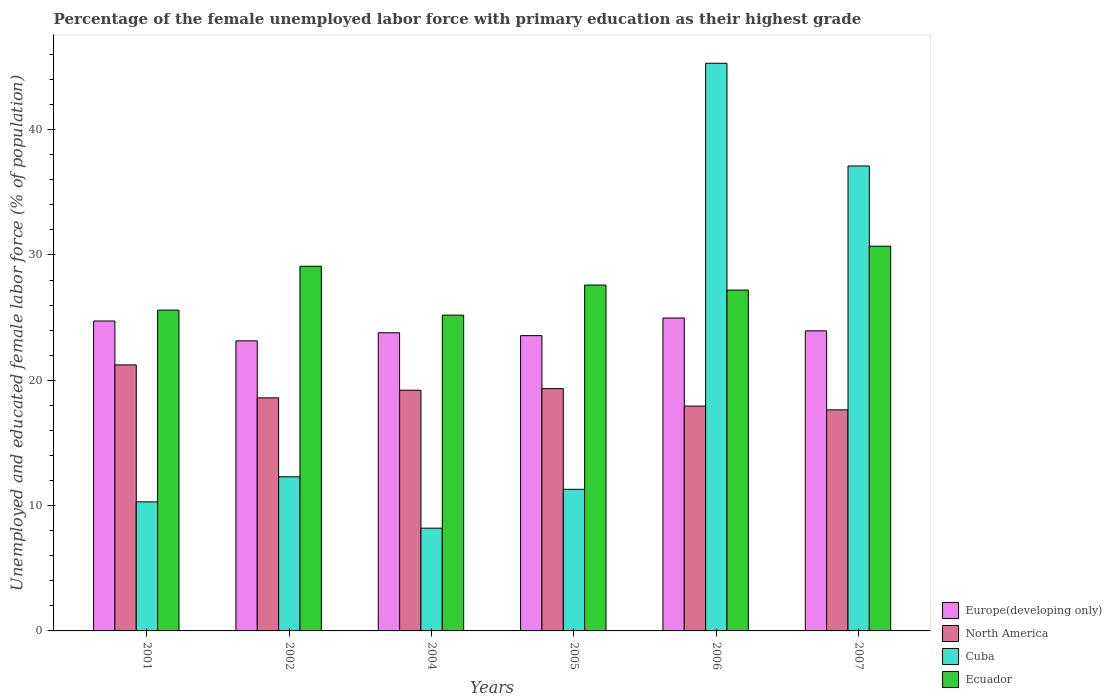How many different coloured bars are there?
Give a very brief answer. 4. How many groups of bars are there?
Give a very brief answer. 6. Are the number of bars per tick equal to the number of legend labels?
Offer a terse response. Yes. Are the number of bars on each tick of the X-axis equal?
Make the answer very short. Yes. How many bars are there on the 1st tick from the right?
Give a very brief answer. 4. What is the label of the 1st group of bars from the left?
Give a very brief answer. 2001. In how many cases, is the number of bars for a given year not equal to the number of legend labels?
Give a very brief answer. 0. What is the percentage of the unemployed female labor force with primary education in North America in 2001?
Give a very brief answer. 21.23. Across all years, what is the maximum percentage of the unemployed female labor force with primary education in Cuba?
Your response must be concise. 45.3. Across all years, what is the minimum percentage of the unemployed female labor force with primary education in Europe(developing only)?
Make the answer very short. 23.15. In which year was the percentage of the unemployed female labor force with primary education in Ecuador maximum?
Give a very brief answer. 2007. What is the total percentage of the unemployed female labor force with primary education in Cuba in the graph?
Offer a very short reply. 124.5. What is the difference between the percentage of the unemployed female labor force with primary education in Cuba in 2002 and that in 2007?
Make the answer very short. -24.8. What is the difference between the percentage of the unemployed female labor force with primary education in Ecuador in 2005 and the percentage of the unemployed female labor force with primary education in North America in 2004?
Provide a short and direct response. 8.39. What is the average percentage of the unemployed female labor force with primary education in Cuba per year?
Give a very brief answer. 20.75. In the year 2002, what is the difference between the percentage of the unemployed female labor force with primary education in Ecuador and percentage of the unemployed female labor force with primary education in Cuba?
Your answer should be very brief. 16.8. In how many years, is the percentage of the unemployed female labor force with primary education in Ecuador greater than 26 %?
Ensure brevity in your answer.  4. What is the ratio of the percentage of the unemployed female labor force with primary education in Ecuador in 2005 to that in 2006?
Keep it short and to the point. 1.01. Is the percentage of the unemployed female labor force with primary education in Cuba in 2002 less than that in 2004?
Provide a short and direct response. No. What is the difference between the highest and the second highest percentage of the unemployed female labor force with primary education in Ecuador?
Keep it short and to the point. 1.6. What is the difference between the highest and the lowest percentage of the unemployed female labor force with primary education in Cuba?
Your response must be concise. 37.1. In how many years, is the percentage of the unemployed female labor force with primary education in North America greater than the average percentage of the unemployed female labor force with primary education in North America taken over all years?
Make the answer very short. 3. Is the sum of the percentage of the unemployed female labor force with primary education in North America in 2002 and 2005 greater than the maximum percentage of the unemployed female labor force with primary education in Europe(developing only) across all years?
Offer a terse response. Yes. Is it the case that in every year, the sum of the percentage of the unemployed female labor force with primary education in Cuba and percentage of the unemployed female labor force with primary education in Ecuador is greater than the sum of percentage of the unemployed female labor force with primary education in North America and percentage of the unemployed female labor force with primary education in Europe(developing only)?
Provide a short and direct response. No. What does the 1st bar from the left in 2006 represents?
Give a very brief answer. Europe(developing only). What does the 4th bar from the right in 2006 represents?
Your answer should be very brief. Europe(developing only). Is it the case that in every year, the sum of the percentage of the unemployed female labor force with primary education in Europe(developing only) and percentage of the unemployed female labor force with primary education in North America is greater than the percentage of the unemployed female labor force with primary education in Ecuador?
Give a very brief answer. Yes. Are all the bars in the graph horizontal?
Your answer should be compact. No. How many years are there in the graph?
Ensure brevity in your answer.  6. Does the graph contain any zero values?
Give a very brief answer. No. Does the graph contain grids?
Give a very brief answer. No. How are the legend labels stacked?
Offer a terse response. Vertical. What is the title of the graph?
Your answer should be very brief. Percentage of the female unemployed labor force with primary education as their highest grade. What is the label or title of the X-axis?
Offer a terse response. Years. What is the label or title of the Y-axis?
Your response must be concise. Unemployed and educated female labor force (% of population). What is the Unemployed and educated female labor force (% of population) of Europe(developing only) in 2001?
Offer a terse response. 24.73. What is the Unemployed and educated female labor force (% of population) of North America in 2001?
Make the answer very short. 21.23. What is the Unemployed and educated female labor force (% of population) in Cuba in 2001?
Ensure brevity in your answer.  10.3. What is the Unemployed and educated female labor force (% of population) in Ecuador in 2001?
Make the answer very short. 25.6. What is the Unemployed and educated female labor force (% of population) of Europe(developing only) in 2002?
Ensure brevity in your answer.  23.15. What is the Unemployed and educated female labor force (% of population) of North America in 2002?
Offer a very short reply. 18.6. What is the Unemployed and educated female labor force (% of population) of Cuba in 2002?
Make the answer very short. 12.3. What is the Unemployed and educated female labor force (% of population) of Ecuador in 2002?
Make the answer very short. 29.1. What is the Unemployed and educated female labor force (% of population) of Europe(developing only) in 2004?
Ensure brevity in your answer.  23.79. What is the Unemployed and educated female labor force (% of population) in North America in 2004?
Provide a succinct answer. 19.21. What is the Unemployed and educated female labor force (% of population) of Cuba in 2004?
Offer a very short reply. 8.2. What is the Unemployed and educated female labor force (% of population) of Ecuador in 2004?
Provide a succinct answer. 25.2. What is the Unemployed and educated female labor force (% of population) of Europe(developing only) in 2005?
Make the answer very short. 23.57. What is the Unemployed and educated female labor force (% of population) of North America in 2005?
Provide a succinct answer. 19.33. What is the Unemployed and educated female labor force (% of population) in Cuba in 2005?
Your answer should be very brief. 11.3. What is the Unemployed and educated female labor force (% of population) of Ecuador in 2005?
Offer a terse response. 27.6. What is the Unemployed and educated female labor force (% of population) of Europe(developing only) in 2006?
Keep it short and to the point. 24.97. What is the Unemployed and educated female labor force (% of population) of North America in 2006?
Ensure brevity in your answer.  17.94. What is the Unemployed and educated female labor force (% of population) of Cuba in 2006?
Ensure brevity in your answer.  45.3. What is the Unemployed and educated female labor force (% of population) of Ecuador in 2006?
Your answer should be very brief. 27.2. What is the Unemployed and educated female labor force (% of population) of Europe(developing only) in 2007?
Provide a short and direct response. 23.95. What is the Unemployed and educated female labor force (% of population) of North America in 2007?
Keep it short and to the point. 17.64. What is the Unemployed and educated female labor force (% of population) of Cuba in 2007?
Make the answer very short. 37.1. What is the Unemployed and educated female labor force (% of population) in Ecuador in 2007?
Offer a very short reply. 30.7. Across all years, what is the maximum Unemployed and educated female labor force (% of population) in Europe(developing only)?
Your answer should be very brief. 24.97. Across all years, what is the maximum Unemployed and educated female labor force (% of population) of North America?
Your answer should be very brief. 21.23. Across all years, what is the maximum Unemployed and educated female labor force (% of population) of Cuba?
Offer a terse response. 45.3. Across all years, what is the maximum Unemployed and educated female labor force (% of population) in Ecuador?
Your response must be concise. 30.7. Across all years, what is the minimum Unemployed and educated female labor force (% of population) in Europe(developing only)?
Keep it short and to the point. 23.15. Across all years, what is the minimum Unemployed and educated female labor force (% of population) in North America?
Your answer should be very brief. 17.64. Across all years, what is the minimum Unemployed and educated female labor force (% of population) in Cuba?
Ensure brevity in your answer.  8.2. Across all years, what is the minimum Unemployed and educated female labor force (% of population) in Ecuador?
Offer a terse response. 25.2. What is the total Unemployed and educated female labor force (% of population) of Europe(developing only) in the graph?
Keep it short and to the point. 144.15. What is the total Unemployed and educated female labor force (% of population) of North America in the graph?
Offer a very short reply. 113.96. What is the total Unemployed and educated female labor force (% of population) of Cuba in the graph?
Provide a short and direct response. 124.5. What is the total Unemployed and educated female labor force (% of population) of Ecuador in the graph?
Your answer should be compact. 165.4. What is the difference between the Unemployed and educated female labor force (% of population) of Europe(developing only) in 2001 and that in 2002?
Your response must be concise. 1.59. What is the difference between the Unemployed and educated female labor force (% of population) of North America in 2001 and that in 2002?
Your answer should be compact. 2.63. What is the difference between the Unemployed and educated female labor force (% of population) in Cuba in 2001 and that in 2002?
Your answer should be compact. -2. What is the difference between the Unemployed and educated female labor force (% of population) of Europe(developing only) in 2001 and that in 2004?
Provide a short and direct response. 0.94. What is the difference between the Unemployed and educated female labor force (% of population) in North America in 2001 and that in 2004?
Offer a very short reply. 2.02. What is the difference between the Unemployed and educated female labor force (% of population) of Cuba in 2001 and that in 2004?
Offer a very short reply. 2.1. What is the difference between the Unemployed and educated female labor force (% of population) of Europe(developing only) in 2001 and that in 2005?
Offer a terse response. 1.17. What is the difference between the Unemployed and educated female labor force (% of population) in North America in 2001 and that in 2005?
Provide a short and direct response. 1.89. What is the difference between the Unemployed and educated female labor force (% of population) of Cuba in 2001 and that in 2005?
Provide a short and direct response. -1. What is the difference between the Unemployed and educated female labor force (% of population) in Ecuador in 2001 and that in 2005?
Ensure brevity in your answer.  -2. What is the difference between the Unemployed and educated female labor force (% of population) in Europe(developing only) in 2001 and that in 2006?
Ensure brevity in your answer.  -0.24. What is the difference between the Unemployed and educated female labor force (% of population) of North America in 2001 and that in 2006?
Offer a terse response. 3.29. What is the difference between the Unemployed and educated female labor force (% of population) in Cuba in 2001 and that in 2006?
Provide a succinct answer. -35. What is the difference between the Unemployed and educated female labor force (% of population) in Europe(developing only) in 2001 and that in 2007?
Offer a terse response. 0.79. What is the difference between the Unemployed and educated female labor force (% of population) of North America in 2001 and that in 2007?
Your answer should be compact. 3.59. What is the difference between the Unemployed and educated female labor force (% of population) in Cuba in 2001 and that in 2007?
Make the answer very short. -26.8. What is the difference between the Unemployed and educated female labor force (% of population) in Ecuador in 2001 and that in 2007?
Your response must be concise. -5.1. What is the difference between the Unemployed and educated female labor force (% of population) of Europe(developing only) in 2002 and that in 2004?
Your answer should be very brief. -0.65. What is the difference between the Unemployed and educated female labor force (% of population) of North America in 2002 and that in 2004?
Provide a short and direct response. -0.61. What is the difference between the Unemployed and educated female labor force (% of population) in Cuba in 2002 and that in 2004?
Provide a short and direct response. 4.1. What is the difference between the Unemployed and educated female labor force (% of population) of Ecuador in 2002 and that in 2004?
Ensure brevity in your answer.  3.9. What is the difference between the Unemployed and educated female labor force (% of population) of Europe(developing only) in 2002 and that in 2005?
Provide a succinct answer. -0.42. What is the difference between the Unemployed and educated female labor force (% of population) of North America in 2002 and that in 2005?
Ensure brevity in your answer.  -0.74. What is the difference between the Unemployed and educated female labor force (% of population) of Cuba in 2002 and that in 2005?
Make the answer very short. 1. What is the difference between the Unemployed and educated female labor force (% of population) of Europe(developing only) in 2002 and that in 2006?
Your answer should be compact. -1.82. What is the difference between the Unemployed and educated female labor force (% of population) of North America in 2002 and that in 2006?
Your response must be concise. 0.66. What is the difference between the Unemployed and educated female labor force (% of population) of Cuba in 2002 and that in 2006?
Offer a terse response. -33. What is the difference between the Unemployed and educated female labor force (% of population) of Ecuador in 2002 and that in 2006?
Keep it short and to the point. 1.9. What is the difference between the Unemployed and educated female labor force (% of population) in Europe(developing only) in 2002 and that in 2007?
Give a very brief answer. -0.8. What is the difference between the Unemployed and educated female labor force (% of population) of North America in 2002 and that in 2007?
Make the answer very short. 0.96. What is the difference between the Unemployed and educated female labor force (% of population) of Cuba in 2002 and that in 2007?
Ensure brevity in your answer.  -24.8. What is the difference between the Unemployed and educated female labor force (% of population) of Ecuador in 2002 and that in 2007?
Your answer should be very brief. -1.6. What is the difference between the Unemployed and educated female labor force (% of population) in Europe(developing only) in 2004 and that in 2005?
Your answer should be very brief. 0.23. What is the difference between the Unemployed and educated female labor force (% of population) of North America in 2004 and that in 2005?
Offer a terse response. -0.13. What is the difference between the Unemployed and educated female labor force (% of population) in Europe(developing only) in 2004 and that in 2006?
Your response must be concise. -1.18. What is the difference between the Unemployed and educated female labor force (% of population) in North America in 2004 and that in 2006?
Provide a succinct answer. 1.26. What is the difference between the Unemployed and educated female labor force (% of population) in Cuba in 2004 and that in 2006?
Offer a very short reply. -37.1. What is the difference between the Unemployed and educated female labor force (% of population) in Europe(developing only) in 2004 and that in 2007?
Provide a short and direct response. -0.15. What is the difference between the Unemployed and educated female labor force (% of population) in North America in 2004 and that in 2007?
Keep it short and to the point. 1.56. What is the difference between the Unemployed and educated female labor force (% of population) of Cuba in 2004 and that in 2007?
Your response must be concise. -28.9. What is the difference between the Unemployed and educated female labor force (% of population) of Ecuador in 2004 and that in 2007?
Your response must be concise. -5.5. What is the difference between the Unemployed and educated female labor force (% of population) of Europe(developing only) in 2005 and that in 2006?
Offer a very short reply. -1.4. What is the difference between the Unemployed and educated female labor force (% of population) of North America in 2005 and that in 2006?
Your answer should be compact. 1.39. What is the difference between the Unemployed and educated female labor force (% of population) of Cuba in 2005 and that in 2006?
Your response must be concise. -34. What is the difference between the Unemployed and educated female labor force (% of population) of Europe(developing only) in 2005 and that in 2007?
Keep it short and to the point. -0.38. What is the difference between the Unemployed and educated female labor force (% of population) of North America in 2005 and that in 2007?
Ensure brevity in your answer.  1.69. What is the difference between the Unemployed and educated female labor force (% of population) of Cuba in 2005 and that in 2007?
Your response must be concise. -25.8. What is the difference between the Unemployed and educated female labor force (% of population) of Europe(developing only) in 2006 and that in 2007?
Ensure brevity in your answer.  1.02. What is the difference between the Unemployed and educated female labor force (% of population) of North America in 2006 and that in 2007?
Provide a succinct answer. 0.3. What is the difference between the Unemployed and educated female labor force (% of population) in Cuba in 2006 and that in 2007?
Make the answer very short. 8.2. What is the difference between the Unemployed and educated female labor force (% of population) in Ecuador in 2006 and that in 2007?
Offer a very short reply. -3.5. What is the difference between the Unemployed and educated female labor force (% of population) in Europe(developing only) in 2001 and the Unemployed and educated female labor force (% of population) in North America in 2002?
Your answer should be compact. 6.13. What is the difference between the Unemployed and educated female labor force (% of population) in Europe(developing only) in 2001 and the Unemployed and educated female labor force (% of population) in Cuba in 2002?
Offer a terse response. 12.43. What is the difference between the Unemployed and educated female labor force (% of population) of Europe(developing only) in 2001 and the Unemployed and educated female labor force (% of population) of Ecuador in 2002?
Your answer should be compact. -4.37. What is the difference between the Unemployed and educated female labor force (% of population) of North America in 2001 and the Unemployed and educated female labor force (% of population) of Cuba in 2002?
Your answer should be compact. 8.93. What is the difference between the Unemployed and educated female labor force (% of population) of North America in 2001 and the Unemployed and educated female labor force (% of population) of Ecuador in 2002?
Offer a terse response. -7.87. What is the difference between the Unemployed and educated female labor force (% of population) of Cuba in 2001 and the Unemployed and educated female labor force (% of population) of Ecuador in 2002?
Provide a short and direct response. -18.8. What is the difference between the Unemployed and educated female labor force (% of population) of Europe(developing only) in 2001 and the Unemployed and educated female labor force (% of population) of North America in 2004?
Your response must be concise. 5.53. What is the difference between the Unemployed and educated female labor force (% of population) of Europe(developing only) in 2001 and the Unemployed and educated female labor force (% of population) of Cuba in 2004?
Make the answer very short. 16.53. What is the difference between the Unemployed and educated female labor force (% of population) in Europe(developing only) in 2001 and the Unemployed and educated female labor force (% of population) in Ecuador in 2004?
Keep it short and to the point. -0.47. What is the difference between the Unemployed and educated female labor force (% of population) of North America in 2001 and the Unemployed and educated female labor force (% of population) of Cuba in 2004?
Offer a very short reply. 13.03. What is the difference between the Unemployed and educated female labor force (% of population) of North America in 2001 and the Unemployed and educated female labor force (% of population) of Ecuador in 2004?
Make the answer very short. -3.97. What is the difference between the Unemployed and educated female labor force (% of population) of Cuba in 2001 and the Unemployed and educated female labor force (% of population) of Ecuador in 2004?
Offer a terse response. -14.9. What is the difference between the Unemployed and educated female labor force (% of population) in Europe(developing only) in 2001 and the Unemployed and educated female labor force (% of population) in North America in 2005?
Your answer should be compact. 5.4. What is the difference between the Unemployed and educated female labor force (% of population) of Europe(developing only) in 2001 and the Unemployed and educated female labor force (% of population) of Cuba in 2005?
Provide a short and direct response. 13.43. What is the difference between the Unemployed and educated female labor force (% of population) in Europe(developing only) in 2001 and the Unemployed and educated female labor force (% of population) in Ecuador in 2005?
Offer a terse response. -2.87. What is the difference between the Unemployed and educated female labor force (% of population) in North America in 2001 and the Unemployed and educated female labor force (% of population) in Cuba in 2005?
Offer a very short reply. 9.93. What is the difference between the Unemployed and educated female labor force (% of population) in North America in 2001 and the Unemployed and educated female labor force (% of population) in Ecuador in 2005?
Make the answer very short. -6.37. What is the difference between the Unemployed and educated female labor force (% of population) of Cuba in 2001 and the Unemployed and educated female labor force (% of population) of Ecuador in 2005?
Offer a very short reply. -17.3. What is the difference between the Unemployed and educated female labor force (% of population) in Europe(developing only) in 2001 and the Unemployed and educated female labor force (% of population) in North America in 2006?
Keep it short and to the point. 6.79. What is the difference between the Unemployed and educated female labor force (% of population) of Europe(developing only) in 2001 and the Unemployed and educated female labor force (% of population) of Cuba in 2006?
Your answer should be very brief. -20.57. What is the difference between the Unemployed and educated female labor force (% of population) of Europe(developing only) in 2001 and the Unemployed and educated female labor force (% of population) of Ecuador in 2006?
Provide a succinct answer. -2.47. What is the difference between the Unemployed and educated female labor force (% of population) of North America in 2001 and the Unemployed and educated female labor force (% of population) of Cuba in 2006?
Offer a terse response. -24.07. What is the difference between the Unemployed and educated female labor force (% of population) in North America in 2001 and the Unemployed and educated female labor force (% of population) in Ecuador in 2006?
Make the answer very short. -5.97. What is the difference between the Unemployed and educated female labor force (% of population) of Cuba in 2001 and the Unemployed and educated female labor force (% of population) of Ecuador in 2006?
Your answer should be compact. -16.9. What is the difference between the Unemployed and educated female labor force (% of population) of Europe(developing only) in 2001 and the Unemployed and educated female labor force (% of population) of North America in 2007?
Provide a short and direct response. 7.09. What is the difference between the Unemployed and educated female labor force (% of population) in Europe(developing only) in 2001 and the Unemployed and educated female labor force (% of population) in Cuba in 2007?
Provide a succinct answer. -12.37. What is the difference between the Unemployed and educated female labor force (% of population) of Europe(developing only) in 2001 and the Unemployed and educated female labor force (% of population) of Ecuador in 2007?
Provide a short and direct response. -5.97. What is the difference between the Unemployed and educated female labor force (% of population) of North America in 2001 and the Unemployed and educated female labor force (% of population) of Cuba in 2007?
Offer a very short reply. -15.87. What is the difference between the Unemployed and educated female labor force (% of population) of North America in 2001 and the Unemployed and educated female labor force (% of population) of Ecuador in 2007?
Your answer should be compact. -9.47. What is the difference between the Unemployed and educated female labor force (% of population) of Cuba in 2001 and the Unemployed and educated female labor force (% of population) of Ecuador in 2007?
Your answer should be compact. -20.4. What is the difference between the Unemployed and educated female labor force (% of population) of Europe(developing only) in 2002 and the Unemployed and educated female labor force (% of population) of North America in 2004?
Ensure brevity in your answer.  3.94. What is the difference between the Unemployed and educated female labor force (% of population) of Europe(developing only) in 2002 and the Unemployed and educated female labor force (% of population) of Cuba in 2004?
Provide a succinct answer. 14.95. What is the difference between the Unemployed and educated female labor force (% of population) of Europe(developing only) in 2002 and the Unemployed and educated female labor force (% of population) of Ecuador in 2004?
Keep it short and to the point. -2.05. What is the difference between the Unemployed and educated female labor force (% of population) of North America in 2002 and the Unemployed and educated female labor force (% of population) of Cuba in 2004?
Your answer should be compact. 10.4. What is the difference between the Unemployed and educated female labor force (% of population) in North America in 2002 and the Unemployed and educated female labor force (% of population) in Ecuador in 2004?
Give a very brief answer. -6.6. What is the difference between the Unemployed and educated female labor force (% of population) in Cuba in 2002 and the Unemployed and educated female labor force (% of population) in Ecuador in 2004?
Give a very brief answer. -12.9. What is the difference between the Unemployed and educated female labor force (% of population) in Europe(developing only) in 2002 and the Unemployed and educated female labor force (% of population) in North America in 2005?
Offer a terse response. 3.81. What is the difference between the Unemployed and educated female labor force (% of population) in Europe(developing only) in 2002 and the Unemployed and educated female labor force (% of population) in Cuba in 2005?
Ensure brevity in your answer.  11.85. What is the difference between the Unemployed and educated female labor force (% of population) of Europe(developing only) in 2002 and the Unemployed and educated female labor force (% of population) of Ecuador in 2005?
Provide a short and direct response. -4.45. What is the difference between the Unemployed and educated female labor force (% of population) of North America in 2002 and the Unemployed and educated female labor force (% of population) of Cuba in 2005?
Your answer should be compact. 7.3. What is the difference between the Unemployed and educated female labor force (% of population) in North America in 2002 and the Unemployed and educated female labor force (% of population) in Ecuador in 2005?
Your response must be concise. -9. What is the difference between the Unemployed and educated female labor force (% of population) of Cuba in 2002 and the Unemployed and educated female labor force (% of population) of Ecuador in 2005?
Keep it short and to the point. -15.3. What is the difference between the Unemployed and educated female labor force (% of population) in Europe(developing only) in 2002 and the Unemployed and educated female labor force (% of population) in North America in 2006?
Provide a succinct answer. 5.2. What is the difference between the Unemployed and educated female labor force (% of population) of Europe(developing only) in 2002 and the Unemployed and educated female labor force (% of population) of Cuba in 2006?
Your answer should be very brief. -22.15. What is the difference between the Unemployed and educated female labor force (% of population) of Europe(developing only) in 2002 and the Unemployed and educated female labor force (% of population) of Ecuador in 2006?
Make the answer very short. -4.05. What is the difference between the Unemployed and educated female labor force (% of population) in North America in 2002 and the Unemployed and educated female labor force (% of population) in Cuba in 2006?
Offer a terse response. -26.7. What is the difference between the Unemployed and educated female labor force (% of population) of North America in 2002 and the Unemployed and educated female labor force (% of population) of Ecuador in 2006?
Ensure brevity in your answer.  -8.6. What is the difference between the Unemployed and educated female labor force (% of population) in Cuba in 2002 and the Unemployed and educated female labor force (% of population) in Ecuador in 2006?
Your response must be concise. -14.9. What is the difference between the Unemployed and educated female labor force (% of population) of Europe(developing only) in 2002 and the Unemployed and educated female labor force (% of population) of North America in 2007?
Provide a succinct answer. 5.5. What is the difference between the Unemployed and educated female labor force (% of population) in Europe(developing only) in 2002 and the Unemployed and educated female labor force (% of population) in Cuba in 2007?
Your answer should be very brief. -13.95. What is the difference between the Unemployed and educated female labor force (% of population) in Europe(developing only) in 2002 and the Unemployed and educated female labor force (% of population) in Ecuador in 2007?
Keep it short and to the point. -7.55. What is the difference between the Unemployed and educated female labor force (% of population) in North America in 2002 and the Unemployed and educated female labor force (% of population) in Cuba in 2007?
Your answer should be compact. -18.5. What is the difference between the Unemployed and educated female labor force (% of population) of North America in 2002 and the Unemployed and educated female labor force (% of population) of Ecuador in 2007?
Make the answer very short. -12.1. What is the difference between the Unemployed and educated female labor force (% of population) of Cuba in 2002 and the Unemployed and educated female labor force (% of population) of Ecuador in 2007?
Your answer should be very brief. -18.4. What is the difference between the Unemployed and educated female labor force (% of population) in Europe(developing only) in 2004 and the Unemployed and educated female labor force (% of population) in North America in 2005?
Offer a very short reply. 4.46. What is the difference between the Unemployed and educated female labor force (% of population) of Europe(developing only) in 2004 and the Unemployed and educated female labor force (% of population) of Cuba in 2005?
Provide a short and direct response. 12.49. What is the difference between the Unemployed and educated female labor force (% of population) in Europe(developing only) in 2004 and the Unemployed and educated female labor force (% of population) in Ecuador in 2005?
Your answer should be very brief. -3.81. What is the difference between the Unemployed and educated female labor force (% of population) of North America in 2004 and the Unemployed and educated female labor force (% of population) of Cuba in 2005?
Keep it short and to the point. 7.91. What is the difference between the Unemployed and educated female labor force (% of population) of North America in 2004 and the Unemployed and educated female labor force (% of population) of Ecuador in 2005?
Provide a short and direct response. -8.39. What is the difference between the Unemployed and educated female labor force (% of population) in Cuba in 2004 and the Unemployed and educated female labor force (% of population) in Ecuador in 2005?
Your answer should be very brief. -19.4. What is the difference between the Unemployed and educated female labor force (% of population) in Europe(developing only) in 2004 and the Unemployed and educated female labor force (% of population) in North America in 2006?
Provide a succinct answer. 5.85. What is the difference between the Unemployed and educated female labor force (% of population) of Europe(developing only) in 2004 and the Unemployed and educated female labor force (% of population) of Cuba in 2006?
Your response must be concise. -21.51. What is the difference between the Unemployed and educated female labor force (% of population) in Europe(developing only) in 2004 and the Unemployed and educated female labor force (% of population) in Ecuador in 2006?
Provide a succinct answer. -3.41. What is the difference between the Unemployed and educated female labor force (% of population) of North America in 2004 and the Unemployed and educated female labor force (% of population) of Cuba in 2006?
Offer a terse response. -26.09. What is the difference between the Unemployed and educated female labor force (% of population) of North America in 2004 and the Unemployed and educated female labor force (% of population) of Ecuador in 2006?
Keep it short and to the point. -7.99. What is the difference between the Unemployed and educated female labor force (% of population) in Cuba in 2004 and the Unemployed and educated female labor force (% of population) in Ecuador in 2006?
Your response must be concise. -19. What is the difference between the Unemployed and educated female labor force (% of population) in Europe(developing only) in 2004 and the Unemployed and educated female labor force (% of population) in North America in 2007?
Provide a succinct answer. 6.15. What is the difference between the Unemployed and educated female labor force (% of population) in Europe(developing only) in 2004 and the Unemployed and educated female labor force (% of population) in Cuba in 2007?
Offer a terse response. -13.31. What is the difference between the Unemployed and educated female labor force (% of population) of Europe(developing only) in 2004 and the Unemployed and educated female labor force (% of population) of Ecuador in 2007?
Keep it short and to the point. -6.91. What is the difference between the Unemployed and educated female labor force (% of population) in North America in 2004 and the Unemployed and educated female labor force (% of population) in Cuba in 2007?
Your answer should be compact. -17.89. What is the difference between the Unemployed and educated female labor force (% of population) in North America in 2004 and the Unemployed and educated female labor force (% of population) in Ecuador in 2007?
Offer a terse response. -11.49. What is the difference between the Unemployed and educated female labor force (% of population) of Cuba in 2004 and the Unemployed and educated female labor force (% of population) of Ecuador in 2007?
Keep it short and to the point. -22.5. What is the difference between the Unemployed and educated female labor force (% of population) in Europe(developing only) in 2005 and the Unemployed and educated female labor force (% of population) in North America in 2006?
Give a very brief answer. 5.62. What is the difference between the Unemployed and educated female labor force (% of population) of Europe(developing only) in 2005 and the Unemployed and educated female labor force (% of population) of Cuba in 2006?
Offer a very short reply. -21.73. What is the difference between the Unemployed and educated female labor force (% of population) of Europe(developing only) in 2005 and the Unemployed and educated female labor force (% of population) of Ecuador in 2006?
Your response must be concise. -3.63. What is the difference between the Unemployed and educated female labor force (% of population) in North America in 2005 and the Unemployed and educated female labor force (% of population) in Cuba in 2006?
Your response must be concise. -25.97. What is the difference between the Unemployed and educated female labor force (% of population) of North America in 2005 and the Unemployed and educated female labor force (% of population) of Ecuador in 2006?
Keep it short and to the point. -7.87. What is the difference between the Unemployed and educated female labor force (% of population) of Cuba in 2005 and the Unemployed and educated female labor force (% of population) of Ecuador in 2006?
Offer a terse response. -15.9. What is the difference between the Unemployed and educated female labor force (% of population) of Europe(developing only) in 2005 and the Unemployed and educated female labor force (% of population) of North America in 2007?
Provide a short and direct response. 5.92. What is the difference between the Unemployed and educated female labor force (% of population) in Europe(developing only) in 2005 and the Unemployed and educated female labor force (% of population) in Cuba in 2007?
Offer a terse response. -13.53. What is the difference between the Unemployed and educated female labor force (% of population) in Europe(developing only) in 2005 and the Unemployed and educated female labor force (% of population) in Ecuador in 2007?
Provide a short and direct response. -7.13. What is the difference between the Unemployed and educated female labor force (% of population) of North America in 2005 and the Unemployed and educated female labor force (% of population) of Cuba in 2007?
Your answer should be compact. -17.77. What is the difference between the Unemployed and educated female labor force (% of population) in North America in 2005 and the Unemployed and educated female labor force (% of population) in Ecuador in 2007?
Offer a very short reply. -11.37. What is the difference between the Unemployed and educated female labor force (% of population) of Cuba in 2005 and the Unemployed and educated female labor force (% of population) of Ecuador in 2007?
Make the answer very short. -19.4. What is the difference between the Unemployed and educated female labor force (% of population) of Europe(developing only) in 2006 and the Unemployed and educated female labor force (% of population) of North America in 2007?
Your answer should be compact. 7.33. What is the difference between the Unemployed and educated female labor force (% of population) of Europe(developing only) in 2006 and the Unemployed and educated female labor force (% of population) of Cuba in 2007?
Offer a terse response. -12.13. What is the difference between the Unemployed and educated female labor force (% of population) of Europe(developing only) in 2006 and the Unemployed and educated female labor force (% of population) of Ecuador in 2007?
Ensure brevity in your answer.  -5.73. What is the difference between the Unemployed and educated female labor force (% of population) of North America in 2006 and the Unemployed and educated female labor force (% of population) of Cuba in 2007?
Provide a succinct answer. -19.16. What is the difference between the Unemployed and educated female labor force (% of population) in North America in 2006 and the Unemployed and educated female labor force (% of population) in Ecuador in 2007?
Your answer should be very brief. -12.76. What is the average Unemployed and educated female labor force (% of population) in Europe(developing only) per year?
Keep it short and to the point. 24.03. What is the average Unemployed and educated female labor force (% of population) in North America per year?
Provide a succinct answer. 18.99. What is the average Unemployed and educated female labor force (% of population) of Cuba per year?
Ensure brevity in your answer.  20.75. What is the average Unemployed and educated female labor force (% of population) in Ecuador per year?
Provide a short and direct response. 27.57. In the year 2001, what is the difference between the Unemployed and educated female labor force (% of population) in Europe(developing only) and Unemployed and educated female labor force (% of population) in North America?
Give a very brief answer. 3.5. In the year 2001, what is the difference between the Unemployed and educated female labor force (% of population) in Europe(developing only) and Unemployed and educated female labor force (% of population) in Cuba?
Your answer should be compact. 14.43. In the year 2001, what is the difference between the Unemployed and educated female labor force (% of population) of Europe(developing only) and Unemployed and educated female labor force (% of population) of Ecuador?
Keep it short and to the point. -0.87. In the year 2001, what is the difference between the Unemployed and educated female labor force (% of population) of North America and Unemployed and educated female labor force (% of population) of Cuba?
Ensure brevity in your answer.  10.93. In the year 2001, what is the difference between the Unemployed and educated female labor force (% of population) in North America and Unemployed and educated female labor force (% of population) in Ecuador?
Provide a succinct answer. -4.37. In the year 2001, what is the difference between the Unemployed and educated female labor force (% of population) of Cuba and Unemployed and educated female labor force (% of population) of Ecuador?
Make the answer very short. -15.3. In the year 2002, what is the difference between the Unemployed and educated female labor force (% of population) of Europe(developing only) and Unemployed and educated female labor force (% of population) of North America?
Keep it short and to the point. 4.55. In the year 2002, what is the difference between the Unemployed and educated female labor force (% of population) in Europe(developing only) and Unemployed and educated female labor force (% of population) in Cuba?
Provide a short and direct response. 10.85. In the year 2002, what is the difference between the Unemployed and educated female labor force (% of population) of Europe(developing only) and Unemployed and educated female labor force (% of population) of Ecuador?
Keep it short and to the point. -5.95. In the year 2002, what is the difference between the Unemployed and educated female labor force (% of population) of North America and Unemployed and educated female labor force (% of population) of Cuba?
Your response must be concise. 6.3. In the year 2002, what is the difference between the Unemployed and educated female labor force (% of population) of North America and Unemployed and educated female labor force (% of population) of Ecuador?
Offer a very short reply. -10.5. In the year 2002, what is the difference between the Unemployed and educated female labor force (% of population) of Cuba and Unemployed and educated female labor force (% of population) of Ecuador?
Give a very brief answer. -16.8. In the year 2004, what is the difference between the Unemployed and educated female labor force (% of population) of Europe(developing only) and Unemployed and educated female labor force (% of population) of North America?
Ensure brevity in your answer.  4.59. In the year 2004, what is the difference between the Unemployed and educated female labor force (% of population) of Europe(developing only) and Unemployed and educated female labor force (% of population) of Cuba?
Your answer should be compact. 15.59. In the year 2004, what is the difference between the Unemployed and educated female labor force (% of population) in Europe(developing only) and Unemployed and educated female labor force (% of population) in Ecuador?
Ensure brevity in your answer.  -1.41. In the year 2004, what is the difference between the Unemployed and educated female labor force (% of population) of North America and Unemployed and educated female labor force (% of population) of Cuba?
Offer a very short reply. 11.01. In the year 2004, what is the difference between the Unemployed and educated female labor force (% of population) of North America and Unemployed and educated female labor force (% of population) of Ecuador?
Your answer should be compact. -5.99. In the year 2005, what is the difference between the Unemployed and educated female labor force (% of population) in Europe(developing only) and Unemployed and educated female labor force (% of population) in North America?
Offer a terse response. 4.23. In the year 2005, what is the difference between the Unemployed and educated female labor force (% of population) in Europe(developing only) and Unemployed and educated female labor force (% of population) in Cuba?
Your answer should be compact. 12.27. In the year 2005, what is the difference between the Unemployed and educated female labor force (% of population) in Europe(developing only) and Unemployed and educated female labor force (% of population) in Ecuador?
Offer a terse response. -4.03. In the year 2005, what is the difference between the Unemployed and educated female labor force (% of population) of North America and Unemployed and educated female labor force (% of population) of Cuba?
Offer a terse response. 8.03. In the year 2005, what is the difference between the Unemployed and educated female labor force (% of population) of North America and Unemployed and educated female labor force (% of population) of Ecuador?
Make the answer very short. -8.27. In the year 2005, what is the difference between the Unemployed and educated female labor force (% of population) in Cuba and Unemployed and educated female labor force (% of population) in Ecuador?
Offer a very short reply. -16.3. In the year 2006, what is the difference between the Unemployed and educated female labor force (% of population) of Europe(developing only) and Unemployed and educated female labor force (% of population) of North America?
Keep it short and to the point. 7.03. In the year 2006, what is the difference between the Unemployed and educated female labor force (% of population) in Europe(developing only) and Unemployed and educated female labor force (% of population) in Cuba?
Provide a succinct answer. -20.33. In the year 2006, what is the difference between the Unemployed and educated female labor force (% of population) in Europe(developing only) and Unemployed and educated female labor force (% of population) in Ecuador?
Your answer should be compact. -2.23. In the year 2006, what is the difference between the Unemployed and educated female labor force (% of population) of North America and Unemployed and educated female labor force (% of population) of Cuba?
Give a very brief answer. -27.36. In the year 2006, what is the difference between the Unemployed and educated female labor force (% of population) in North America and Unemployed and educated female labor force (% of population) in Ecuador?
Keep it short and to the point. -9.26. In the year 2007, what is the difference between the Unemployed and educated female labor force (% of population) of Europe(developing only) and Unemployed and educated female labor force (% of population) of North America?
Ensure brevity in your answer.  6.3. In the year 2007, what is the difference between the Unemployed and educated female labor force (% of population) in Europe(developing only) and Unemployed and educated female labor force (% of population) in Cuba?
Your answer should be compact. -13.15. In the year 2007, what is the difference between the Unemployed and educated female labor force (% of population) of Europe(developing only) and Unemployed and educated female labor force (% of population) of Ecuador?
Give a very brief answer. -6.75. In the year 2007, what is the difference between the Unemployed and educated female labor force (% of population) in North America and Unemployed and educated female labor force (% of population) in Cuba?
Your answer should be very brief. -19.46. In the year 2007, what is the difference between the Unemployed and educated female labor force (% of population) in North America and Unemployed and educated female labor force (% of population) in Ecuador?
Provide a succinct answer. -13.06. In the year 2007, what is the difference between the Unemployed and educated female labor force (% of population) of Cuba and Unemployed and educated female labor force (% of population) of Ecuador?
Your answer should be compact. 6.4. What is the ratio of the Unemployed and educated female labor force (% of population) of Europe(developing only) in 2001 to that in 2002?
Make the answer very short. 1.07. What is the ratio of the Unemployed and educated female labor force (% of population) of North America in 2001 to that in 2002?
Ensure brevity in your answer.  1.14. What is the ratio of the Unemployed and educated female labor force (% of population) of Cuba in 2001 to that in 2002?
Offer a very short reply. 0.84. What is the ratio of the Unemployed and educated female labor force (% of population) in Ecuador in 2001 to that in 2002?
Ensure brevity in your answer.  0.88. What is the ratio of the Unemployed and educated female labor force (% of population) of Europe(developing only) in 2001 to that in 2004?
Your response must be concise. 1.04. What is the ratio of the Unemployed and educated female labor force (% of population) of North America in 2001 to that in 2004?
Your answer should be compact. 1.11. What is the ratio of the Unemployed and educated female labor force (% of population) in Cuba in 2001 to that in 2004?
Your response must be concise. 1.26. What is the ratio of the Unemployed and educated female labor force (% of population) in Ecuador in 2001 to that in 2004?
Provide a short and direct response. 1.02. What is the ratio of the Unemployed and educated female labor force (% of population) in Europe(developing only) in 2001 to that in 2005?
Give a very brief answer. 1.05. What is the ratio of the Unemployed and educated female labor force (% of population) of North America in 2001 to that in 2005?
Your answer should be compact. 1.1. What is the ratio of the Unemployed and educated female labor force (% of population) of Cuba in 2001 to that in 2005?
Provide a short and direct response. 0.91. What is the ratio of the Unemployed and educated female labor force (% of population) in Ecuador in 2001 to that in 2005?
Provide a short and direct response. 0.93. What is the ratio of the Unemployed and educated female labor force (% of population) in North America in 2001 to that in 2006?
Provide a short and direct response. 1.18. What is the ratio of the Unemployed and educated female labor force (% of population) in Cuba in 2001 to that in 2006?
Provide a succinct answer. 0.23. What is the ratio of the Unemployed and educated female labor force (% of population) in Ecuador in 2001 to that in 2006?
Give a very brief answer. 0.94. What is the ratio of the Unemployed and educated female labor force (% of population) in Europe(developing only) in 2001 to that in 2007?
Keep it short and to the point. 1.03. What is the ratio of the Unemployed and educated female labor force (% of population) in North America in 2001 to that in 2007?
Ensure brevity in your answer.  1.2. What is the ratio of the Unemployed and educated female labor force (% of population) of Cuba in 2001 to that in 2007?
Your response must be concise. 0.28. What is the ratio of the Unemployed and educated female labor force (% of population) in Ecuador in 2001 to that in 2007?
Provide a succinct answer. 0.83. What is the ratio of the Unemployed and educated female labor force (% of population) in Europe(developing only) in 2002 to that in 2004?
Your answer should be compact. 0.97. What is the ratio of the Unemployed and educated female labor force (% of population) in North America in 2002 to that in 2004?
Keep it short and to the point. 0.97. What is the ratio of the Unemployed and educated female labor force (% of population) in Cuba in 2002 to that in 2004?
Ensure brevity in your answer.  1.5. What is the ratio of the Unemployed and educated female labor force (% of population) in Ecuador in 2002 to that in 2004?
Your answer should be compact. 1.15. What is the ratio of the Unemployed and educated female labor force (% of population) in Europe(developing only) in 2002 to that in 2005?
Provide a succinct answer. 0.98. What is the ratio of the Unemployed and educated female labor force (% of population) of Cuba in 2002 to that in 2005?
Provide a succinct answer. 1.09. What is the ratio of the Unemployed and educated female labor force (% of population) in Ecuador in 2002 to that in 2005?
Offer a terse response. 1.05. What is the ratio of the Unemployed and educated female labor force (% of population) of Europe(developing only) in 2002 to that in 2006?
Give a very brief answer. 0.93. What is the ratio of the Unemployed and educated female labor force (% of population) in North America in 2002 to that in 2006?
Offer a very short reply. 1.04. What is the ratio of the Unemployed and educated female labor force (% of population) of Cuba in 2002 to that in 2006?
Give a very brief answer. 0.27. What is the ratio of the Unemployed and educated female labor force (% of population) of Ecuador in 2002 to that in 2006?
Provide a succinct answer. 1.07. What is the ratio of the Unemployed and educated female labor force (% of population) in Europe(developing only) in 2002 to that in 2007?
Your response must be concise. 0.97. What is the ratio of the Unemployed and educated female labor force (% of population) of North America in 2002 to that in 2007?
Provide a succinct answer. 1.05. What is the ratio of the Unemployed and educated female labor force (% of population) of Cuba in 2002 to that in 2007?
Keep it short and to the point. 0.33. What is the ratio of the Unemployed and educated female labor force (% of population) in Ecuador in 2002 to that in 2007?
Ensure brevity in your answer.  0.95. What is the ratio of the Unemployed and educated female labor force (% of population) of Europe(developing only) in 2004 to that in 2005?
Provide a succinct answer. 1.01. What is the ratio of the Unemployed and educated female labor force (% of population) of Cuba in 2004 to that in 2005?
Offer a terse response. 0.73. What is the ratio of the Unemployed and educated female labor force (% of population) in Europe(developing only) in 2004 to that in 2006?
Give a very brief answer. 0.95. What is the ratio of the Unemployed and educated female labor force (% of population) in North America in 2004 to that in 2006?
Offer a very short reply. 1.07. What is the ratio of the Unemployed and educated female labor force (% of population) of Cuba in 2004 to that in 2006?
Ensure brevity in your answer.  0.18. What is the ratio of the Unemployed and educated female labor force (% of population) in Ecuador in 2004 to that in 2006?
Provide a succinct answer. 0.93. What is the ratio of the Unemployed and educated female labor force (% of population) in Europe(developing only) in 2004 to that in 2007?
Your response must be concise. 0.99. What is the ratio of the Unemployed and educated female labor force (% of population) of North America in 2004 to that in 2007?
Offer a terse response. 1.09. What is the ratio of the Unemployed and educated female labor force (% of population) of Cuba in 2004 to that in 2007?
Your response must be concise. 0.22. What is the ratio of the Unemployed and educated female labor force (% of population) of Ecuador in 2004 to that in 2007?
Make the answer very short. 0.82. What is the ratio of the Unemployed and educated female labor force (% of population) in Europe(developing only) in 2005 to that in 2006?
Offer a very short reply. 0.94. What is the ratio of the Unemployed and educated female labor force (% of population) of North America in 2005 to that in 2006?
Offer a terse response. 1.08. What is the ratio of the Unemployed and educated female labor force (% of population) of Cuba in 2005 to that in 2006?
Offer a very short reply. 0.25. What is the ratio of the Unemployed and educated female labor force (% of population) of Ecuador in 2005 to that in 2006?
Keep it short and to the point. 1.01. What is the ratio of the Unemployed and educated female labor force (% of population) of Europe(developing only) in 2005 to that in 2007?
Offer a terse response. 0.98. What is the ratio of the Unemployed and educated female labor force (% of population) in North America in 2005 to that in 2007?
Give a very brief answer. 1.1. What is the ratio of the Unemployed and educated female labor force (% of population) in Cuba in 2005 to that in 2007?
Provide a succinct answer. 0.3. What is the ratio of the Unemployed and educated female labor force (% of population) in Ecuador in 2005 to that in 2007?
Provide a short and direct response. 0.9. What is the ratio of the Unemployed and educated female labor force (% of population) in Europe(developing only) in 2006 to that in 2007?
Make the answer very short. 1.04. What is the ratio of the Unemployed and educated female labor force (% of population) in North America in 2006 to that in 2007?
Offer a very short reply. 1.02. What is the ratio of the Unemployed and educated female labor force (% of population) of Cuba in 2006 to that in 2007?
Offer a very short reply. 1.22. What is the ratio of the Unemployed and educated female labor force (% of population) in Ecuador in 2006 to that in 2007?
Offer a very short reply. 0.89. What is the difference between the highest and the second highest Unemployed and educated female labor force (% of population) in Europe(developing only)?
Your response must be concise. 0.24. What is the difference between the highest and the second highest Unemployed and educated female labor force (% of population) in North America?
Provide a succinct answer. 1.89. What is the difference between the highest and the second highest Unemployed and educated female labor force (% of population) of Ecuador?
Your response must be concise. 1.6. What is the difference between the highest and the lowest Unemployed and educated female labor force (% of population) in Europe(developing only)?
Your answer should be very brief. 1.82. What is the difference between the highest and the lowest Unemployed and educated female labor force (% of population) of North America?
Offer a very short reply. 3.59. What is the difference between the highest and the lowest Unemployed and educated female labor force (% of population) in Cuba?
Give a very brief answer. 37.1. 